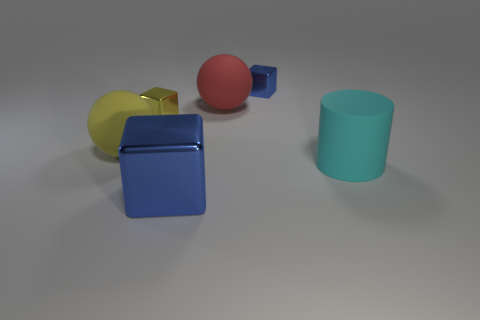What number of balls have the same size as the yellow cube? 0 